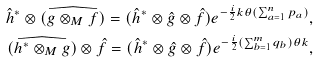<formula> <loc_0><loc_0><loc_500><loc_500>\hat { h } ^ { * } \otimes ( \widehat { g \otimes _ { M } f } ) = ( \hat { h } ^ { * } \otimes \hat { g } \otimes \hat { f } ) e ^ { - \frac { i } { 2 } k \theta ( \sum _ { a = 1 } ^ { n } p _ { a } ) } , \\ ( \widehat { h ^ { * } \otimes _ { M } g } ) \otimes \hat { f } = ( \hat { h } ^ { * } \otimes \hat { g } \otimes \hat { f } ) e ^ { - \frac { i } { 2 } ( \sum _ { b = 1 } ^ { m } q _ { b } ) \theta k } ,</formula> 